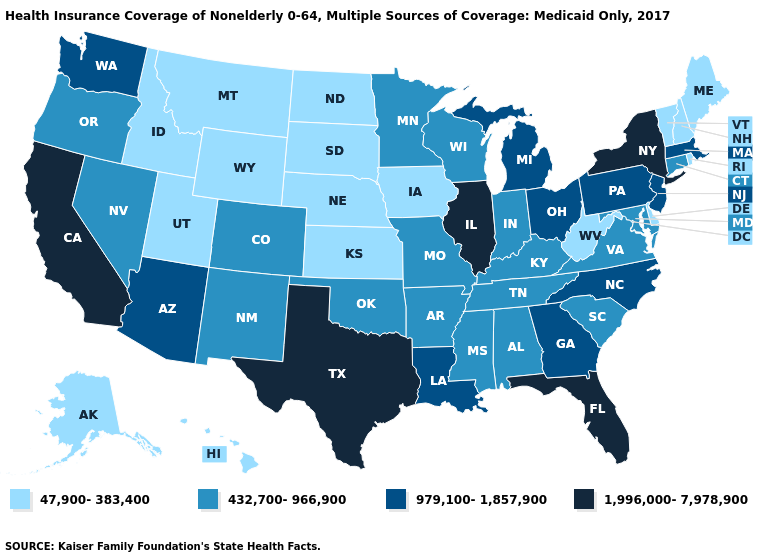What is the lowest value in the USA?
Be succinct. 47,900-383,400. Name the states that have a value in the range 47,900-383,400?
Be succinct. Alaska, Delaware, Hawaii, Idaho, Iowa, Kansas, Maine, Montana, Nebraska, New Hampshire, North Dakota, Rhode Island, South Dakota, Utah, Vermont, West Virginia, Wyoming. Name the states that have a value in the range 979,100-1,857,900?
Answer briefly. Arizona, Georgia, Louisiana, Massachusetts, Michigan, New Jersey, North Carolina, Ohio, Pennsylvania, Washington. Which states have the highest value in the USA?
Answer briefly. California, Florida, Illinois, New York, Texas. What is the lowest value in the South?
Quick response, please. 47,900-383,400. Among the states that border Vermont , which have the lowest value?
Answer briefly. New Hampshire. Name the states that have a value in the range 979,100-1,857,900?
Be succinct. Arizona, Georgia, Louisiana, Massachusetts, Michigan, New Jersey, North Carolina, Ohio, Pennsylvania, Washington. How many symbols are there in the legend?
Short answer required. 4. What is the value of West Virginia?
Quick response, please. 47,900-383,400. Which states have the lowest value in the USA?
Concise answer only. Alaska, Delaware, Hawaii, Idaho, Iowa, Kansas, Maine, Montana, Nebraska, New Hampshire, North Dakota, Rhode Island, South Dakota, Utah, Vermont, West Virginia, Wyoming. Does West Virginia have the lowest value in the USA?
Keep it brief. Yes. Among the states that border Iowa , does Minnesota have the lowest value?
Concise answer only. No. Does Indiana have the same value as South Carolina?
Write a very short answer. Yes. What is the value of Arizona?
Short answer required. 979,100-1,857,900. What is the highest value in the Northeast ?
Concise answer only. 1,996,000-7,978,900. 